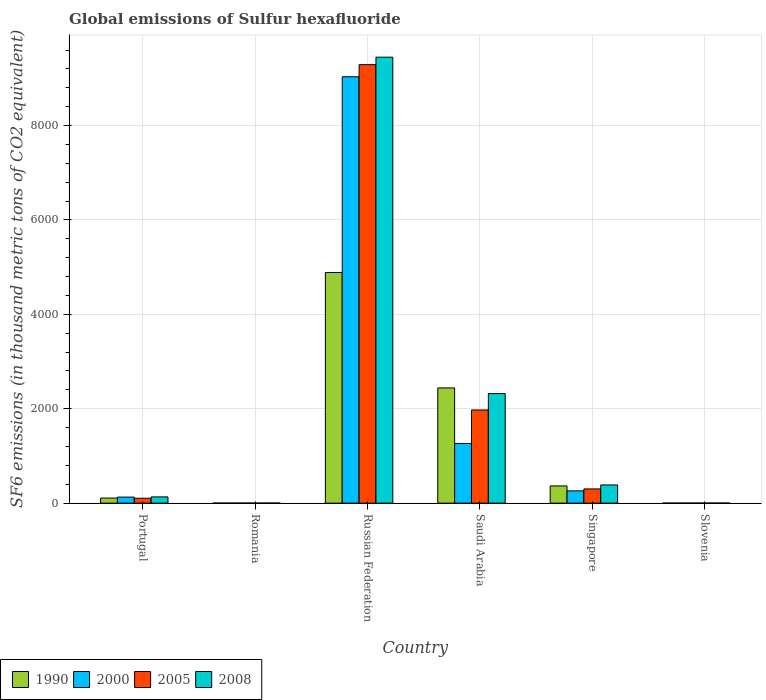How many different coloured bars are there?
Keep it short and to the point. 4. How many groups of bars are there?
Offer a terse response. 6. Are the number of bars on each tick of the X-axis equal?
Offer a very short reply. Yes. How many bars are there on the 3rd tick from the left?
Offer a terse response. 4. How many bars are there on the 6th tick from the right?
Your response must be concise. 4. What is the label of the 4th group of bars from the left?
Offer a terse response. Saudi Arabia. What is the global emissions of Sulfur hexafluoride in 2000 in Singapore?
Make the answer very short. 259.8. Across all countries, what is the maximum global emissions of Sulfur hexafluoride in 2000?
Give a very brief answer. 9033.2. In which country was the global emissions of Sulfur hexafluoride in 2000 maximum?
Your answer should be compact. Russian Federation. In which country was the global emissions of Sulfur hexafluoride in 2005 minimum?
Your answer should be compact. Romania. What is the total global emissions of Sulfur hexafluoride in 2005 in the graph?
Keep it short and to the point. 1.17e+04. What is the difference between the global emissions of Sulfur hexafluoride in 2000 in Portugal and that in Saudi Arabia?
Give a very brief answer. -1136.6. What is the difference between the global emissions of Sulfur hexafluoride in 2000 in Romania and the global emissions of Sulfur hexafluoride in 2008 in Slovenia?
Offer a terse response. -0.3. What is the average global emissions of Sulfur hexafluoride in 2005 per country?
Your answer should be very brief. 1945.52. What is the difference between the global emissions of Sulfur hexafluoride of/in 2005 and global emissions of Sulfur hexafluoride of/in 1990 in Slovenia?
Offer a terse response. 0.6. What is the ratio of the global emissions of Sulfur hexafluoride in 1990 in Portugal to that in Singapore?
Make the answer very short. 0.3. What is the difference between the highest and the second highest global emissions of Sulfur hexafluoride in 2000?
Your answer should be very brief. -7768.6. What is the difference between the highest and the lowest global emissions of Sulfur hexafluoride in 2005?
Keep it short and to the point. 9287.7. Is the sum of the global emissions of Sulfur hexafluoride in 2008 in Portugal and Romania greater than the maximum global emissions of Sulfur hexafluoride in 1990 across all countries?
Offer a very short reply. No. What does the 4th bar from the left in Romania represents?
Your answer should be compact. 2008. What does the 1st bar from the right in Portugal represents?
Offer a very short reply. 2008. What is the difference between two consecutive major ticks on the Y-axis?
Your answer should be compact. 2000. Does the graph contain grids?
Offer a very short reply. Yes. Where does the legend appear in the graph?
Your answer should be compact. Bottom left. How many legend labels are there?
Provide a succinct answer. 4. How are the legend labels stacked?
Give a very brief answer. Horizontal. What is the title of the graph?
Provide a succinct answer. Global emissions of Sulfur hexafluoride. What is the label or title of the Y-axis?
Your response must be concise. SF6 emissions (in thousand metric tons of CO2 equivalent). What is the SF6 emissions (in thousand metric tons of CO2 equivalent) of 1990 in Portugal?
Provide a succinct answer. 108. What is the SF6 emissions (in thousand metric tons of CO2 equivalent) of 2000 in Portugal?
Your answer should be compact. 128. What is the SF6 emissions (in thousand metric tons of CO2 equivalent) in 2005 in Portugal?
Offer a terse response. 103.8. What is the SF6 emissions (in thousand metric tons of CO2 equivalent) in 2008 in Portugal?
Make the answer very short. 132.4. What is the SF6 emissions (in thousand metric tons of CO2 equivalent) in 1990 in Romania?
Your answer should be very brief. 1.6. What is the SF6 emissions (in thousand metric tons of CO2 equivalent) in 2000 in Romania?
Your answer should be compact. 2. What is the SF6 emissions (in thousand metric tons of CO2 equivalent) in 2005 in Romania?
Your answer should be compact. 2.2. What is the SF6 emissions (in thousand metric tons of CO2 equivalent) of 1990 in Russian Federation?
Your answer should be very brief. 4886.8. What is the SF6 emissions (in thousand metric tons of CO2 equivalent) in 2000 in Russian Federation?
Provide a short and direct response. 9033.2. What is the SF6 emissions (in thousand metric tons of CO2 equivalent) in 2005 in Russian Federation?
Make the answer very short. 9289.9. What is the SF6 emissions (in thousand metric tons of CO2 equivalent) in 2008 in Russian Federation?
Keep it short and to the point. 9448.2. What is the SF6 emissions (in thousand metric tons of CO2 equivalent) of 1990 in Saudi Arabia?
Your answer should be compact. 2441.3. What is the SF6 emissions (in thousand metric tons of CO2 equivalent) in 2000 in Saudi Arabia?
Your answer should be compact. 1264.6. What is the SF6 emissions (in thousand metric tons of CO2 equivalent) in 2005 in Saudi Arabia?
Give a very brief answer. 1973.8. What is the SF6 emissions (in thousand metric tons of CO2 equivalent) of 2008 in Saudi Arabia?
Give a very brief answer. 2321.8. What is the SF6 emissions (in thousand metric tons of CO2 equivalent) of 1990 in Singapore?
Give a very brief answer. 364.7. What is the SF6 emissions (in thousand metric tons of CO2 equivalent) of 2000 in Singapore?
Keep it short and to the point. 259.8. What is the SF6 emissions (in thousand metric tons of CO2 equivalent) of 2005 in Singapore?
Your answer should be compact. 301.2. What is the SF6 emissions (in thousand metric tons of CO2 equivalent) in 2008 in Singapore?
Make the answer very short. 385.5. What is the SF6 emissions (in thousand metric tons of CO2 equivalent) of 2000 in Slovenia?
Keep it short and to the point. 2. What is the SF6 emissions (in thousand metric tons of CO2 equivalent) in 2008 in Slovenia?
Offer a very short reply. 2.3. Across all countries, what is the maximum SF6 emissions (in thousand metric tons of CO2 equivalent) in 1990?
Your answer should be compact. 4886.8. Across all countries, what is the maximum SF6 emissions (in thousand metric tons of CO2 equivalent) in 2000?
Offer a very short reply. 9033.2. Across all countries, what is the maximum SF6 emissions (in thousand metric tons of CO2 equivalent) of 2005?
Your response must be concise. 9289.9. Across all countries, what is the maximum SF6 emissions (in thousand metric tons of CO2 equivalent) in 2008?
Give a very brief answer. 9448.2. Across all countries, what is the minimum SF6 emissions (in thousand metric tons of CO2 equivalent) in 2000?
Provide a succinct answer. 2. Across all countries, what is the minimum SF6 emissions (in thousand metric tons of CO2 equivalent) of 2005?
Your answer should be compact. 2.2. Across all countries, what is the minimum SF6 emissions (in thousand metric tons of CO2 equivalent) in 2008?
Ensure brevity in your answer.  2.3. What is the total SF6 emissions (in thousand metric tons of CO2 equivalent) of 1990 in the graph?
Provide a succinct answer. 7804. What is the total SF6 emissions (in thousand metric tons of CO2 equivalent) in 2000 in the graph?
Provide a short and direct response. 1.07e+04. What is the total SF6 emissions (in thousand metric tons of CO2 equivalent) of 2005 in the graph?
Ensure brevity in your answer.  1.17e+04. What is the total SF6 emissions (in thousand metric tons of CO2 equivalent) in 2008 in the graph?
Ensure brevity in your answer.  1.23e+04. What is the difference between the SF6 emissions (in thousand metric tons of CO2 equivalent) in 1990 in Portugal and that in Romania?
Ensure brevity in your answer.  106.4. What is the difference between the SF6 emissions (in thousand metric tons of CO2 equivalent) of 2000 in Portugal and that in Romania?
Your response must be concise. 126. What is the difference between the SF6 emissions (in thousand metric tons of CO2 equivalent) of 2005 in Portugal and that in Romania?
Offer a terse response. 101.6. What is the difference between the SF6 emissions (in thousand metric tons of CO2 equivalent) of 2008 in Portugal and that in Romania?
Keep it short and to the point. 130.1. What is the difference between the SF6 emissions (in thousand metric tons of CO2 equivalent) in 1990 in Portugal and that in Russian Federation?
Provide a short and direct response. -4778.8. What is the difference between the SF6 emissions (in thousand metric tons of CO2 equivalent) in 2000 in Portugal and that in Russian Federation?
Your answer should be very brief. -8905.2. What is the difference between the SF6 emissions (in thousand metric tons of CO2 equivalent) of 2005 in Portugal and that in Russian Federation?
Make the answer very short. -9186.1. What is the difference between the SF6 emissions (in thousand metric tons of CO2 equivalent) of 2008 in Portugal and that in Russian Federation?
Your answer should be compact. -9315.8. What is the difference between the SF6 emissions (in thousand metric tons of CO2 equivalent) of 1990 in Portugal and that in Saudi Arabia?
Your answer should be very brief. -2333.3. What is the difference between the SF6 emissions (in thousand metric tons of CO2 equivalent) of 2000 in Portugal and that in Saudi Arabia?
Offer a terse response. -1136.6. What is the difference between the SF6 emissions (in thousand metric tons of CO2 equivalent) in 2005 in Portugal and that in Saudi Arabia?
Make the answer very short. -1870. What is the difference between the SF6 emissions (in thousand metric tons of CO2 equivalent) in 2008 in Portugal and that in Saudi Arabia?
Ensure brevity in your answer.  -2189.4. What is the difference between the SF6 emissions (in thousand metric tons of CO2 equivalent) in 1990 in Portugal and that in Singapore?
Ensure brevity in your answer.  -256.7. What is the difference between the SF6 emissions (in thousand metric tons of CO2 equivalent) in 2000 in Portugal and that in Singapore?
Provide a succinct answer. -131.8. What is the difference between the SF6 emissions (in thousand metric tons of CO2 equivalent) in 2005 in Portugal and that in Singapore?
Provide a succinct answer. -197.4. What is the difference between the SF6 emissions (in thousand metric tons of CO2 equivalent) in 2008 in Portugal and that in Singapore?
Keep it short and to the point. -253.1. What is the difference between the SF6 emissions (in thousand metric tons of CO2 equivalent) in 1990 in Portugal and that in Slovenia?
Offer a terse response. 106.4. What is the difference between the SF6 emissions (in thousand metric tons of CO2 equivalent) in 2000 in Portugal and that in Slovenia?
Ensure brevity in your answer.  126. What is the difference between the SF6 emissions (in thousand metric tons of CO2 equivalent) of 2005 in Portugal and that in Slovenia?
Your answer should be compact. 101.6. What is the difference between the SF6 emissions (in thousand metric tons of CO2 equivalent) of 2008 in Portugal and that in Slovenia?
Make the answer very short. 130.1. What is the difference between the SF6 emissions (in thousand metric tons of CO2 equivalent) in 1990 in Romania and that in Russian Federation?
Ensure brevity in your answer.  -4885.2. What is the difference between the SF6 emissions (in thousand metric tons of CO2 equivalent) in 2000 in Romania and that in Russian Federation?
Your response must be concise. -9031.2. What is the difference between the SF6 emissions (in thousand metric tons of CO2 equivalent) of 2005 in Romania and that in Russian Federation?
Your answer should be very brief. -9287.7. What is the difference between the SF6 emissions (in thousand metric tons of CO2 equivalent) in 2008 in Romania and that in Russian Federation?
Give a very brief answer. -9445.9. What is the difference between the SF6 emissions (in thousand metric tons of CO2 equivalent) of 1990 in Romania and that in Saudi Arabia?
Offer a very short reply. -2439.7. What is the difference between the SF6 emissions (in thousand metric tons of CO2 equivalent) of 2000 in Romania and that in Saudi Arabia?
Your answer should be very brief. -1262.6. What is the difference between the SF6 emissions (in thousand metric tons of CO2 equivalent) of 2005 in Romania and that in Saudi Arabia?
Give a very brief answer. -1971.6. What is the difference between the SF6 emissions (in thousand metric tons of CO2 equivalent) in 2008 in Romania and that in Saudi Arabia?
Keep it short and to the point. -2319.5. What is the difference between the SF6 emissions (in thousand metric tons of CO2 equivalent) in 1990 in Romania and that in Singapore?
Provide a succinct answer. -363.1. What is the difference between the SF6 emissions (in thousand metric tons of CO2 equivalent) of 2000 in Romania and that in Singapore?
Your answer should be compact. -257.8. What is the difference between the SF6 emissions (in thousand metric tons of CO2 equivalent) of 2005 in Romania and that in Singapore?
Offer a terse response. -299. What is the difference between the SF6 emissions (in thousand metric tons of CO2 equivalent) in 2008 in Romania and that in Singapore?
Keep it short and to the point. -383.2. What is the difference between the SF6 emissions (in thousand metric tons of CO2 equivalent) in 2000 in Romania and that in Slovenia?
Make the answer very short. 0. What is the difference between the SF6 emissions (in thousand metric tons of CO2 equivalent) in 1990 in Russian Federation and that in Saudi Arabia?
Your answer should be very brief. 2445.5. What is the difference between the SF6 emissions (in thousand metric tons of CO2 equivalent) of 2000 in Russian Federation and that in Saudi Arabia?
Ensure brevity in your answer.  7768.6. What is the difference between the SF6 emissions (in thousand metric tons of CO2 equivalent) of 2005 in Russian Federation and that in Saudi Arabia?
Provide a short and direct response. 7316.1. What is the difference between the SF6 emissions (in thousand metric tons of CO2 equivalent) in 2008 in Russian Federation and that in Saudi Arabia?
Offer a terse response. 7126.4. What is the difference between the SF6 emissions (in thousand metric tons of CO2 equivalent) of 1990 in Russian Federation and that in Singapore?
Offer a terse response. 4522.1. What is the difference between the SF6 emissions (in thousand metric tons of CO2 equivalent) in 2000 in Russian Federation and that in Singapore?
Give a very brief answer. 8773.4. What is the difference between the SF6 emissions (in thousand metric tons of CO2 equivalent) of 2005 in Russian Federation and that in Singapore?
Make the answer very short. 8988.7. What is the difference between the SF6 emissions (in thousand metric tons of CO2 equivalent) in 2008 in Russian Federation and that in Singapore?
Make the answer very short. 9062.7. What is the difference between the SF6 emissions (in thousand metric tons of CO2 equivalent) of 1990 in Russian Federation and that in Slovenia?
Offer a very short reply. 4885.2. What is the difference between the SF6 emissions (in thousand metric tons of CO2 equivalent) of 2000 in Russian Federation and that in Slovenia?
Make the answer very short. 9031.2. What is the difference between the SF6 emissions (in thousand metric tons of CO2 equivalent) of 2005 in Russian Federation and that in Slovenia?
Provide a succinct answer. 9287.7. What is the difference between the SF6 emissions (in thousand metric tons of CO2 equivalent) in 2008 in Russian Federation and that in Slovenia?
Your answer should be very brief. 9445.9. What is the difference between the SF6 emissions (in thousand metric tons of CO2 equivalent) of 1990 in Saudi Arabia and that in Singapore?
Make the answer very short. 2076.6. What is the difference between the SF6 emissions (in thousand metric tons of CO2 equivalent) in 2000 in Saudi Arabia and that in Singapore?
Give a very brief answer. 1004.8. What is the difference between the SF6 emissions (in thousand metric tons of CO2 equivalent) in 2005 in Saudi Arabia and that in Singapore?
Your response must be concise. 1672.6. What is the difference between the SF6 emissions (in thousand metric tons of CO2 equivalent) of 2008 in Saudi Arabia and that in Singapore?
Keep it short and to the point. 1936.3. What is the difference between the SF6 emissions (in thousand metric tons of CO2 equivalent) in 1990 in Saudi Arabia and that in Slovenia?
Your response must be concise. 2439.7. What is the difference between the SF6 emissions (in thousand metric tons of CO2 equivalent) of 2000 in Saudi Arabia and that in Slovenia?
Keep it short and to the point. 1262.6. What is the difference between the SF6 emissions (in thousand metric tons of CO2 equivalent) of 2005 in Saudi Arabia and that in Slovenia?
Offer a terse response. 1971.6. What is the difference between the SF6 emissions (in thousand metric tons of CO2 equivalent) of 2008 in Saudi Arabia and that in Slovenia?
Provide a short and direct response. 2319.5. What is the difference between the SF6 emissions (in thousand metric tons of CO2 equivalent) of 1990 in Singapore and that in Slovenia?
Ensure brevity in your answer.  363.1. What is the difference between the SF6 emissions (in thousand metric tons of CO2 equivalent) of 2000 in Singapore and that in Slovenia?
Your answer should be compact. 257.8. What is the difference between the SF6 emissions (in thousand metric tons of CO2 equivalent) in 2005 in Singapore and that in Slovenia?
Ensure brevity in your answer.  299. What is the difference between the SF6 emissions (in thousand metric tons of CO2 equivalent) of 2008 in Singapore and that in Slovenia?
Your answer should be compact. 383.2. What is the difference between the SF6 emissions (in thousand metric tons of CO2 equivalent) of 1990 in Portugal and the SF6 emissions (in thousand metric tons of CO2 equivalent) of 2000 in Romania?
Offer a very short reply. 106. What is the difference between the SF6 emissions (in thousand metric tons of CO2 equivalent) of 1990 in Portugal and the SF6 emissions (in thousand metric tons of CO2 equivalent) of 2005 in Romania?
Your answer should be compact. 105.8. What is the difference between the SF6 emissions (in thousand metric tons of CO2 equivalent) of 1990 in Portugal and the SF6 emissions (in thousand metric tons of CO2 equivalent) of 2008 in Romania?
Provide a short and direct response. 105.7. What is the difference between the SF6 emissions (in thousand metric tons of CO2 equivalent) in 2000 in Portugal and the SF6 emissions (in thousand metric tons of CO2 equivalent) in 2005 in Romania?
Your answer should be compact. 125.8. What is the difference between the SF6 emissions (in thousand metric tons of CO2 equivalent) of 2000 in Portugal and the SF6 emissions (in thousand metric tons of CO2 equivalent) of 2008 in Romania?
Your answer should be compact. 125.7. What is the difference between the SF6 emissions (in thousand metric tons of CO2 equivalent) of 2005 in Portugal and the SF6 emissions (in thousand metric tons of CO2 equivalent) of 2008 in Romania?
Give a very brief answer. 101.5. What is the difference between the SF6 emissions (in thousand metric tons of CO2 equivalent) in 1990 in Portugal and the SF6 emissions (in thousand metric tons of CO2 equivalent) in 2000 in Russian Federation?
Give a very brief answer. -8925.2. What is the difference between the SF6 emissions (in thousand metric tons of CO2 equivalent) in 1990 in Portugal and the SF6 emissions (in thousand metric tons of CO2 equivalent) in 2005 in Russian Federation?
Provide a succinct answer. -9181.9. What is the difference between the SF6 emissions (in thousand metric tons of CO2 equivalent) in 1990 in Portugal and the SF6 emissions (in thousand metric tons of CO2 equivalent) in 2008 in Russian Federation?
Provide a short and direct response. -9340.2. What is the difference between the SF6 emissions (in thousand metric tons of CO2 equivalent) in 2000 in Portugal and the SF6 emissions (in thousand metric tons of CO2 equivalent) in 2005 in Russian Federation?
Your response must be concise. -9161.9. What is the difference between the SF6 emissions (in thousand metric tons of CO2 equivalent) of 2000 in Portugal and the SF6 emissions (in thousand metric tons of CO2 equivalent) of 2008 in Russian Federation?
Give a very brief answer. -9320.2. What is the difference between the SF6 emissions (in thousand metric tons of CO2 equivalent) in 2005 in Portugal and the SF6 emissions (in thousand metric tons of CO2 equivalent) in 2008 in Russian Federation?
Make the answer very short. -9344.4. What is the difference between the SF6 emissions (in thousand metric tons of CO2 equivalent) in 1990 in Portugal and the SF6 emissions (in thousand metric tons of CO2 equivalent) in 2000 in Saudi Arabia?
Your answer should be very brief. -1156.6. What is the difference between the SF6 emissions (in thousand metric tons of CO2 equivalent) of 1990 in Portugal and the SF6 emissions (in thousand metric tons of CO2 equivalent) of 2005 in Saudi Arabia?
Provide a short and direct response. -1865.8. What is the difference between the SF6 emissions (in thousand metric tons of CO2 equivalent) in 1990 in Portugal and the SF6 emissions (in thousand metric tons of CO2 equivalent) in 2008 in Saudi Arabia?
Give a very brief answer. -2213.8. What is the difference between the SF6 emissions (in thousand metric tons of CO2 equivalent) in 2000 in Portugal and the SF6 emissions (in thousand metric tons of CO2 equivalent) in 2005 in Saudi Arabia?
Offer a very short reply. -1845.8. What is the difference between the SF6 emissions (in thousand metric tons of CO2 equivalent) of 2000 in Portugal and the SF6 emissions (in thousand metric tons of CO2 equivalent) of 2008 in Saudi Arabia?
Your answer should be very brief. -2193.8. What is the difference between the SF6 emissions (in thousand metric tons of CO2 equivalent) of 2005 in Portugal and the SF6 emissions (in thousand metric tons of CO2 equivalent) of 2008 in Saudi Arabia?
Ensure brevity in your answer.  -2218. What is the difference between the SF6 emissions (in thousand metric tons of CO2 equivalent) of 1990 in Portugal and the SF6 emissions (in thousand metric tons of CO2 equivalent) of 2000 in Singapore?
Provide a succinct answer. -151.8. What is the difference between the SF6 emissions (in thousand metric tons of CO2 equivalent) of 1990 in Portugal and the SF6 emissions (in thousand metric tons of CO2 equivalent) of 2005 in Singapore?
Ensure brevity in your answer.  -193.2. What is the difference between the SF6 emissions (in thousand metric tons of CO2 equivalent) of 1990 in Portugal and the SF6 emissions (in thousand metric tons of CO2 equivalent) of 2008 in Singapore?
Provide a short and direct response. -277.5. What is the difference between the SF6 emissions (in thousand metric tons of CO2 equivalent) of 2000 in Portugal and the SF6 emissions (in thousand metric tons of CO2 equivalent) of 2005 in Singapore?
Keep it short and to the point. -173.2. What is the difference between the SF6 emissions (in thousand metric tons of CO2 equivalent) in 2000 in Portugal and the SF6 emissions (in thousand metric tons of CO2 equivalent) in 2008 in Singapore?
Make the answer very short. -257.5. What is the difference between the SF6 emissions (in thousand metric tons of CO2 equivalent) in 2005 in Portugal and the SF6 emissions (in thousand metric tons of CO2 equivalent) in 2008 in Singapore?
Offer a terse response. -281.7. What is the difference between the SF6 emissions (in thousand metric tons of CO2 equivalent) in 1990 in Portugal and the SF6 emissions (in thousand metric tons of CO2 equivalent) in 2000 in Slovenia?
Offer a terse response. 106. What is the difference between the SF6 emissions (in thousand metric tons of CO2 equivalent) of 1990 in Portugal and the SF6 emissions (in thousand metric tons of CO2 equivalent) of 2005 in Slovenia?
Keep it short and to the point. 105.8. What is the difference between the SF6 emissions (in thousand metric tons of CO2 equivalent) in 1990 in Portugal and the SF6 emissions (in thousand metric tons of CO2 equivalent) in 2008 in Slovenia?
Your answer should be very brief. 105.7. What is the difference between the SF6 emissions (in thousand metric tons of CO2 equivalent) in 2000 in Portugal and the SF6 emissions (in thousand metric tons of CO2 equivalent) in 2005 in Slovenia?
Offer a very short reply. 125.8. What is the difference between the SF6 emissions (in thousand metric tons of CO2 equivalent) of 2000 in Portugal and the SF6 emissions (in thousand metric tons of CO2 equivalent) of 2008 in Slovenia?
Provide a succinct answer. 125.7. What is the difference between the SF6 emissions (in thousand metric tons of CO2 equivalent) of 2005 in Portugal and the SF6 emissions (in thousand metric tons of CO2 equivalent) of 2008 in Slovenia?
Give a very brief answer. 101.5. What is the difference between the SF6 emissions (in thousand metric tons of CO2 equivalent) in 1990 in Romania and the SF6 emissions (in thousand metric tons of CO2 equivalent) in 2000 in Russian Federation?
Your answer should be compact. -9031.6. What is the difference between the SF6 emissions (in thousand metric tons of CO2 equivalent) in 1990 in Romania and the SF6 emissions (in thousand metric tons of CO2 equivalent) in 2005 in Russian Federation?
Give a very brief answer. -9288.3. What is the difference between the SF6 emissions (in thousand metric tons of CO2 equivalent) in 1990 in Romania and the SF6 emissions (in thousand metric tons of CO2 equivalent) in 2008 in Russian Federation?
Offer a terse response. -9446.6. What is the difference between the SF6 emissions (in thousand metric tons of CO2 equivalent) in 2000 in Romania and the SF6 emissions (in thousand metric tons of CO2 equivalent) in 2005 in Russian Federation?
Your answer should be compact. -9287.9. What is the difference between the SF6 emissions (in thousand metric tons of CO2 equivalent) in 2000 in Romania and the SF6 emissions (in thousand metric tons of CO2 equivalent) in 2008 in Russian Federation?
Ensure brevity in your answer.  -9446.2. What is the difference between the SF6 emissions (in thousand metric tons of CO2 equivalent) in 2005 in Romania and the SF6 emissions (in thousand metric tons of CO2 equivalent) in 2008 in Russian Federation?
Your answer should be compact. -9446. What is the difference between the SF6 emissions (in thousand metric tons of CO2 equivalent) of 1990 in Romania and the SF6 emissions (in thousand metric tons of CO2 equivalent) of 2000 in Saudi Arabia?
Offer a terse response. -1263. What is the difference between the SF6 emissions (in thousand metric tons of CO2 equivalent) of 1990 in Romania and the SF6 emissions (in thousand metric tons of CO2 equivalent) of 2005 in Saudi Arabia?
Offer a terse response. -1972.2. What is the difference between the SF6 emissions (in thousand metric tons of CO2 equivalent) in 1990 in Romania and the SF6 emissions (in thousand metric tons of CO2 equivalent) in 2008 in Saudi Arabia?
Give a very brief answer. -2320.2. What is the difference between the SF6 emissions (in thousand metric tons of CO2 equivalent) of 2000 in Romania and the SF6 emissions (in thousand metric tons of CO2 equivalent) of 2005 in Saudi Arabia?
Your response must be concise. -1971.8. What is the difference between the SF6 emissions (in thousand metric tons of CO2 equivalent) in 2000 in Romania and the SF6 emissions (in thousand metric tons of CO2 equivalent) in 2008 in Saudi Arabia?
Provide a succinct answer. -2319.8. What is the difference between the SF6 emissions (in thousand metric tons of CO2 equivalent) of 2005 in Romania and the SF6 emissions (in thousand metric tons of CO2 equivalent) of 2008 in Saudi Arabia?
Offer a very short reply. -2319.6. What is the difference between the SF6 emissions (in thousand metric tons of CO2 equivalent) in 1990 in Romania and the SF6 emissions (in thousand metric tons of CO2 equivalent) in 2000 in Singapore?
Provide a succinct answer. -258.2. What is the difference between the SF6 emissions (in thousand metric tons of CO2 equivalent) in 1990 in Romania and the SF6 emissions (in thousand metric tons of CO2 equivalent) in 2005 in Singapore?
Give a very brief answer. -299.6. What is the difference between the SF6 emissions (in thousand metric tons of CO2 equivalent) in 1990 in Romania and the SF6 emissions (in thousand metric tons of CO2 equivalent) in 2008 in Singapore?
Your answer should be compact. -383.9. What is the difference between the SF6 emissions (in thousand metric tons of CO2 equivalent) in 2000 in Romania and the SF6 emissions (in thousand metric tons of CO2 equivalent) in 2005 in Singapore?
Offer a terse response. -299.2. What is the difference between the SF6 emissions (in thousand metric tons of CO2 equivalent) in 2000 in Romania and the SF6 emissions (in thousand metric tons of CO2 equivalent) in 2008 in Singapore?
Your answer should be compact. -383.5. What is the difference between the SF6 emissions (in thousand metric tons of CO2 equivalent) in 2005 in Romania and the SF6 emissions (in thousand metric tons of CO2 equivalent) in 2008 in Singapore?
Offer a very short reply. -383.3. What is the difference between the SF6 emissions (in thousand metric tons of CO2 equivalent) of 1990 in Romania and the SF6 emissions (in thousand metric tons of CO2 equivalent) of 2000 in Slovenia?
Keep it short and to the point. -0.4. What is the difference between the SF6 emissions (in thousand metric tons of CO2 equivalent) of 1990 in Romania and the SF6 emissions (in thousand metric tons of CO2 equivalent) of 2005 in Slovenia?
Provide a succinct answer. -0.6. What is the difference between the SF6 emissions (in thousand metric tons of CO2 equivalent) in 2000 in Romania and the SF6 emissions (in thousand metric tons of CO2 equivalent) in 2005 in Slovenia?
Provide a short and direct response. -0.2. What is the difference between the SF6 emissions (in thousand metric tons of CO2 equivalent) of 2005 in Romania and the SF6 emissions (in thousand metric tons of CO2 equivalent) of 2008 in Slovenia?
Keep it short and to the point. -0.1. What is the difference between the SF6 emissions (in thousand metric tons of CO2 equivalent) in 1990 in Russian Federation and the SF6 emissions (in thousand metric tons of CO2 equivalent) in 2000 in Saudi Arabia?
Keep it short and to the point. 3622.2. What is the difference between the SF6 emissions (in thousand metric tons of CO2 equivalent) of 1990 in Russian Federation and the SF6 emissions (in thousand metric tons of CO2 equivalent) of 2005 in Saudi Arabia?
Provide a succinct answer. 2913. What is the difference between the SF6 emissions (in thousand metric tons of CO2 equivalent) in 1990 in Russian Federation and the SF6 emissions (in thousand metric tons of CO2 equivalent) in 2008 in Saudi Arabia?
Offer a very short reply. 2565. What is the difference between the SF6 emissions (in thousand metric tons of CO2 equivalent) in 2000 in Russian Federation and the SF6 emissions (in thousand metric tons of CO2 equivalent) in 2005 in Saudi Arabia?
Provide a short and direct response. 7059.4. What is the difference between the SF6 emissions (in thousand metric tons of CO2 equivalent) in 2000 in Russian Federation and the SF6 emissions (in thousand metric tons of CO2 equivalent) in 2008 in Saudi Arabia?
Give a very brief answer. 6711.4. What is the difference between the SF6 emissions (in thousand metric tons of CO2 equivalent) of 2005 in Russian Federation and the SF6 emissions (in thousand metric tons of CO2 equivalent) of 2008 in Saudi Arabia?
Your answer should be very brief. 6968.1. What is the difference between the SF6 emissions (in thousand metric tons of CO2 equivalent) in 1990 in Russian Federation and the SF6 emissions (in thousand metric tons of CO2 equivalent) in 2000 in Singapore?
Your answer should be very brief. 4627. What is the difference between the SF6 emissions (in thousand metric tons of CO2 equivalent) of 1990 in Russian Federation and the SF6 emissions (in thousand metric tons of CO2 equivalent) of 2005 in Singapore?
Your answer should be compact. 4585.6. What is the difference between the SF6 emissions (in thousand metric tons of CO2 equivalent) of 1990 in Russian Federation and the SF6 emissions (in thousand metric tons of CO2 equivalent) of 2008 in Singapore?
Make the answer very short. 4501.3. What is the difference between the SF6 emissions (in thousand metric tons of CO2 equivalent) of 2000 in Russian Federation and the SF6 emissions (in thousand metric tons of CO2 equivalent) of 2005 in Singapore?
Give a very brief answer. 8732. What is the difference between the SF6 emissions (in thousand metric tons of CO2 equivalent) in 2000 in Russian Federation and the SF6 emissions (in thousand metric tons of CO2 equivalent) in 2008 in Singapore?
Provide a short and direct response. 8647.7. What is the difference between the SF6 emissions (in thousand metric tons of CO2 equivalent) of 2005 in Russian Federation and the SF6 emissions (in thousand metric tons of CO2 equivalent) of 2008 in Singapore?
Keep it short and to the point. 8904.4. What is the difference between the SF6 emissions (in thousand metric tons of CO2 equivalent) of 1990 in Russian Federation and the SF6 emissions (in thousand metric tons of CO2 equivalent) of 2000 in Slovenia?
Ensure brevity in your answer.  4884.8. What is the difference between the SF6 emissions (in thousand metric tons of CO2 equivalent) of 1990 in Russian Federation and the SF6 emissions (in thousand metric tons of CO2 equivalent) of 2005 in Slovenia?
Provide a succinct answer. 4884.6. What is the difference between the SF6 emissions (in thousand metric tons of CO2 equivalent) of 1990 in Russian Federation and the SF6 emissions (in thousand metric tons of CO2 equivalent) of 2008 in Slovenia?
Your response must be concise. 4884.5. What is the difference between the SF6 emissions (in thousand metric tons of CO2 equivalent) of 2000 in Russian Federation and the SF6 emissions (in thousand metric tons of CO2 equivalent) of 2005 in Slovenia?
Provide a short and direct response. 9031. What is the difference between the SF6 emissions (in thousand metric tons of CO2 equivalent) of 2000 in Russian Federation and the SF6 emissions (in thousand metric tons of CO2 equivalent) of 2008 in Slovenia?
Your answer should be compact. 9030.9. What is the difference between the SF6 emissions (in thousand metric tons of CO2 equivalent) of 2005 in Russian Federation and the SF6 emissions (in thousand metric tons of CO2 equivalent) of 2008 in Slovenia?
Your response must be concise. 9287.6. What is the difference between the SF6 emissions (in thousand metric tons of CO2 equivalent) in 1990 in Saudi Arabia and the SF6 emissions (in thousand metric tons of CO2 equivalent) in 2000 in Singapore?
Give a very brief answer. 2181.5. What is the difference between the SF6 emissions (in thousand metric tons of CO2 equivalent) of 1990 in Saudi Arabia and the SF6 emissions (in thousand metric tons of CO2 equivalent) of 2005 in Singapore?
Provide a short and direct response. 2140.1. What is the difference between the SF6 emissions (in thousand metric tons of CO2 equivalent) in 1990 in Saudi Arabia and the SF6 emissions (in thousand metric tons of CO2 equivalent) in 2008 in Singapore?
Offer a very short reply. 2055.8. What is the difference between the SF6 emissions (in thousand metric tons of CO2 equivalent) of 2000 in Saudi Arabia and the SF6 emissions (in thousand metric tons of CO2 equivalent) of 2005 in Singapore?
Your answer should be compact. 963.4. What is the difference between the SF6 emissions (in thousand metric tons of CO2 equivalent) of 2000 in Saudi Arabia and the SF6 emissions (in thousand metric tons of CO2 equivalent) of 2008 in Singapore?
Your answer should be very brief. 879.1. What is the difference between the SF6 emissions (in thousand metric tons of CO2 equivalent) in 2005 in Saudi Arabia and the SF6 emissions (in thousand metric tons of CO2 equivalent) in 2008 in Singapore?
Offer a terse response. 1588.3. What is the difference between the SF6 emissions (in thousand metric tons of CO2 equivalent) of 1990 in Saudi Arabia and the SF6 emissions (in thousand metric tons of CO2 equivalent) of 2000 in Slovenia?
Your answer should be compact. 2439.3. What is the difference between the SF6 emissions (in thousand metric tons of CO2 equivalent) in 1990 in Saudi Arabia and the SF6 emissions (in thousand metric tons of CO2 equivalent) in 2005 in Slovenia?
Offer a very short reply. 2439.1. What is the difference between the SF6 emissions (in thousand metric tons of CO2 equivalent) of 1990 in Saudi Arabia and the SF6 emissions (in thousand metric tons of CO2 equivalent) of 2008 in Slovenia?
Give a very brief answer. 2439. What is the difference between the SF6 emissions (in thousand metric tons of CO2 equivalent) in 2000 in Saudi Arabia and the SF6 emissions (in thousand metric tons of CO2 equivalent) in 2005 in Slovenia?
Provide a short and direct response. 1262.4. What is the difference between the SF6 emissions (in thousand metric tons of CO2 equivalent) of 2000 in Saudi Arabia and the SF6 emissions (in thousand metric tons of CO2 equivalent) of 2008 in Slovenia?
Offer a terse response. 1262.3. What is the difference between the SF6 emissions (in thousand metric tons of CO2 equivalent) in 2005 in Saudi Arabia and the SF6 emissions (in thousand metric tons of CO2 equivalent) in 2008 in Slovenia?
Offer a terse response. 1971.5. What is the difference between the SF6 emissions (in thousand metric tons of CO2 equivalent) of 1990 in Singapore and the SF6 emissions (in thousand metric tons of CO2 equivalent) of 2000 in Slovenia?
Your response must be concise. 362.7. What is the difference between the SF6 emissions (in thousand metric tons of CO2 equivalent) in 1990 in Singapore and the SF6 emissions (in thousand metric tons of CO2 equivalent) in 2005 in Slovenia?
Your answer should be compact. 362.5. What is the difference between the SF6 emissions (in thousand metric tons of CO2 equivalent) in 1990 in Singapore and the SF6 emissions (in thousand metric tons of CO2 equivalent) in 2008 in Slovenia?
Ensure brevity in your answer.  362.4. What is the difference between the SF6 emissions (in thousand metric tons of CO2 equivalent) in 2000 in Singapore and the SF6 emissions (in thousand metric tons of CO2 equivalent) in 2005 in Slovenia?
Provide a short and direct response. 257.6. What is the difference between the SF6 emissions (in thousand metric tons of CO2 equivalent) in 2000 in Singapore and the SF6 emissions (in thousand metric tons of CO2 equivalent) in 2008 in Slovenia?
Your response must be concise. 257.5. What is the difference between the SF6 emissions (in thousand metric tons of CO2 equivalent) of 2005 in Singapore and the SF6 emissions (in thousand metric tons of CO2 equivalent) of 2008 in Slovenia?
Keep it short and to the point. 298.9. What is the average SF6 emissions (in thousand metric tons of CO2 equivalent) in 1990 per country?
Keep it short and to the point. 1300.67. What is the average SF6 emissions (in thousand metric tons of CO2 equivalent) in 2000 per country?
Give a very brief answer. 1781.6. What is the average SF6 emissions (in thousand metric tons of CO2 equivalent) of 2005 per country?
Ensure brevity in your answer.  1945.52. What is the average SF6 emissions (in thousand metric tons of CO2 equivalent) of 2008 per country?
Offer a very short reply. 2048.75. What is the difference between the SF6 emissions (in thousand metric tons of CO2 equivalent) of 1990 and SF6 emissions (in thousand metric tons of CO2 equivalent) of 2008 in Portugal?
Offer a terse response. -24.4. What is the difference between the SF6 emissions (in thousand metric tons of CO2 equivalent) in 2000 and SF6 emissions (in thousand metric tons of CO2 equivalent) in 2005 in Portugal?
Your answer should be compact. 24.2. What is the difference between the SF6 emissions (in thousand metric tons of CO2 equivalent) of 2005 and SF6 emissions (in thousand metric tons of CO2 equivalent) of 2008 in Portugal?
Keep it short and to the point. -28.6. What is the difference between the SF6 emissions (in thousand metric tons of CO2 equivalent) in 2000 and SF6 emissions (in thousand metric tons of CO2 equivalent) in 2005 in Romania?
Your answer should be compact. -0.2. What is the difference between the SF6 emissions (in thousand metric tons of CO2 equivalent) of 1990 and SF6 emissions (in thousand metric tons of CO2 equivalent) of 2000 in Russian Federation?
Your response must be concise. -4146.4. What is the difference between the SF6 emissions (in thousand metric tons of CO2 equivalent) of 1990 and SF6 emissions (in thousand metric tons of CO2 equivalent) of 2005 in Russian Federation?
Make the answer very short. -4403.1. What is the difference between the SF6 emissions (in thousand metric tons of CO2 equivalent) in 1990 and SF6 emissions (in thousand metric tons of CO2 equivalent) in 2008 in Russian Federation?
Make the answer very short. -4561.4. What is the difference between the SF6 emissions (in thousand metric tons of CO2 equivalent) of 2000 and SF6 emissions (in thousand metric tons of CO2 equivalent) of 2005 in Russian Federation?
Your answer should be compact. -256.7. What is the difference between the SF6 emissions (in thousand metric tons of CO2 equivalent) of 2000 and SF6 emissions (in thousand metric tons of CO2 equivalent) of 2008 in Russian Federation?
Provide a short and direct response. -415. What is the difference between the SF6 emissions (in thousand metric tons of CO2 equivalent) in 2005 and SF6 emissions (in thousand metric tons of CO2 equivalent) in 2008 in Russian Federation?
Your response must be concise. -158.3. What is the difference between the SF6 emissions (in thousand metric tons of CO2 equivalent) in 1990 and SF6 emissions (in thousand metric tons of CO2 equivalent) in 2000 in Saudi Arabia?
Ensure brevity in your answer.  1176.7. What is the difference between the SF6 emissions (in thousand metric tons of CO2 equivalent) of 1990 and SF6 emissions (in thousand metric tons of CO2 equivalent) of 2005 in Saudi Arabia?
Give a very brief answer. 467.5. What is the difference between the SF6 emissions (in thousand metric tons of CO2 equivalent) of 1990 and SF6 emissions (in thousand metric tons of CO2 equivalent) of 2008 in Saudi Arabia?
Provide a succinct answer. 119.5. What is the difference between the SF6 emissions (in thousand metric tons of CO2 equivalent) in 2000 and SF6 emissions (in thousand metric tons of CO2 equivalent) in 2005 in Saudi Arabia?
Your response must be concise. -709.2. What is the difference between the SF6 emissions (in thousand metric tons of CO2 equivalent) of 2000 and SF6 emissions (in thousand metric tons of CO2 equivalent) of 2008 in Saudi Arabia?
Offer a very short reply. -1057.2. What is the difference between the SF6 emissions (in thousand metric tons of CO2 equivalent) of 2005 and SF6 emissions (in thousand metric tons of CO2 equivalent) of 2008 in Saudi Arabia?
Offer a very short reply. -348. What is the difference between the SF6 emissions (in thousand metric tons of CO2 equivalent) in 1990 and SF6 emissions (in thousand metric tons of CO2 equivalent) in 2000 in Singapore?
Keep it short and to the point. 104.9. What is the difference between the SF6 emissions (in thousand metric tons of CO2 equivalent) of 1990 and SF6 emissions (in thousand metric tons of CO2 equivalent) of 2005 in Singapore?
Ensure brevity in your answer.  63.5. What is the difference between the SF6 emissions (in thousand metric tons of CO2 equivalent) of 1990 and SF6 emissions (in thousand metric tons of CO2 equivalent) of 2008 in Singapore?
Keep it short and to the point. -20.8. What is the difference between the SF6 emissions (in thousand metric tons of CO2 equivalent) of 2000 and SF6 emissions (in thousand metric tons of CO2 equivalent) of 2005 in Singapore?
Your answer should be compact. -41.4. What is the difference between the SF6 emissions (in thousand metric tons of CO2 equivalent) in 2000 and SF6 emissions (in thousand metric tons of CO2 equivalent) in 2008 in Singapore?
Offer a terse response. -125.7. What is the difference between the SF6 emissions (in thousand metric tons of CO2 equivalent) in 2005 and SF6 emissions (in thousand metric tons of CO2 equivalent) in 2008 in Singapore?
Ensure brevity in your answer.  -84.3. What is the difference between the SF6 emissions (in thousand metric tons of CO2 equivalent) of 1990 and SF6 emissions (in thousand metric tons of CO2 equivalent) of 2000 in Slovenia?
Offer a terse response. -0.4. What is the difference between the SF6 emissions (in thousand metric tons of CO2 equivalent) in 1990 and SF6 emissions (in thousand metric tons of CO2 equivalent) in 2005 in Slovenia?
Your answer should be compact. -0.6. What is the difference between the SF6 emissions (in thousand metric tons of CO2 equivalent) in 1990 and SF6 emissions (in thousand metric tons of CO2 equivalent) in 2008 in Slovenia?
Offer a very short reply. -0.7. What is the difference between the SF6 emissions (in thousand metric tons of CO2 equivalent) of 2005 and SF6 emissions (in thousand metric tons of CO2 equivalent) of 2008 in Slovenia?
Make the answer very short. -0.1. What is the ratio of the SF6 emissions (in thousand metric tons of CO2 equivalent) of 1990 in Portugal to that in Romania?
Provide a succinct answer. 67.5. What is the ratio of the SF6 emissions (in thousand metric tons of CO2 equivalent) in 2005 in Portugal to that in Romania?
Your response must be concise. 47.18. What is the ratio of the SF6 emissions (in thousand metric tons of CO2 equivalent) in 2008 in Portugal to that in Romania?
Keep it short and to the point. 57.57. What is the ratio of the SF6 emissions (in thousand metric tons of CO2 equivalent) in 1990 in Portugal to that in Russian Federation?
Your response must be concise. 0.02. What is the ratio of the SF6 emissions (in thousand metric tons of CO2 equivalent) in 2000 in Portugal to that in Russian Federation?
Make the answer very short. 0.01. What is the ratio of the SF6 emissions (in thousand metric tons of CO2 equivalent) of 2005 in Portugal to that in Russian Federation?
Offer a terse response. 0.01. What is the ratio of the SF6 emissions (in thousand metric tons of CO2 equivalent) in 2008 in Portugal to that in Russian Federation?
Your response must be concise. 0.01. What is the ratio of the SF6 emissions (in thousand metric tons of CO2 equivalent) of 1990 in Portugal to that in Saudi Arabia?
Provide a short and direct response. 0.04. What is the ratio of the SF6 emissions (in thousand metric tons of CO2 equivalent) in 2000 in Portugal to that in Saudi Arabia?
Your answer should be compact. 0.1. What is the ratio of the SF6 emissions (in thousand metric tons of CO2 equivalent) in 2005 in Portugal to that in Saudi Arabia?
Your response must be concise. 0.05. What is the ratio of the SF6 emissions (in thousand metric tons of CO2 equivalent) in 2008 in Portugal to that in Saudi Arabia?
Provide a succinct answer. 0.06. What is the ratio of the SF6 emissions (in thousand metric tons of CO2 equivalent) of 1990 in Portugal to that in Singapore?
Make the answer very short. 0.3. What is the ratio of the SF6 emissions (in thousand metric tons of CO2 equivalent) of 2000 in Portugal to that in Singapore?
Your answer should be very brief. 0.49. What is the ratio of the SF6 emissions (in thousand metric tons of CO2 equivalent) in 2005 in Portugal to that in Singapore?
Offer a terse response. 0.34. What is the ratio of the SF6 emissions (in thousand metric tons of CO2 equivalent) of 2008 in Portugal to that in Singapore?
Offer a very short reply. 0.34. What is the ratio of the SF6 emissions (in thousand metric tons of CO2 equivalent) of 1990 in Portugal to that in Slovenia?
Your answer should be very brief. 67.5. What is the ratio of the SF6 emissions (in thousand metric tons of CO2 equivalent) of 2005 in Portugal to that in Slovenia?
Your response must be concise. 47.18. What is the ratio of the SF6 emissions (in thousand metric tons of CO2 equivalent) of 2008 in Portugal to that in Slovenia?
Keep it short and to the point. 57.57. What is the ratio of the SF6 emissions (in thousand metric tons of CO2 equivalent) of 2000 in Romania to that in Russian Federation?
Your answer should be very brief. 0. What is the ratio of the SF6 emissions (in thousand metric tons of CO2 equivalent) in 1990 in Romania to that in Saudi Arabia?
Your answer should be very brief. 0. What is the ratio of the SF6 emissions (in thousand metric tons of CO2 equivalent) in 2000 in Romania to that in Saudi Arabia?
Keep it short and to the point. 0. What is the ratio of the SF6 emissions (in thousand metric tons of CO2 equivalent) in 2005 in Romania to that in Saudi Arabia?
Provide a succinct answer. 0. What is the ratio of the SF6 emissions (in thousand metric tons of CO2 equivalent) in 2008 in Romania to that in Saudi Arabia?
Your response must be concise. 0. What is the ratio of the SF6 emissions (in thousand metric tons of CO2 equivalent) in 1990 in Romania to that in Singapore?
Ensure brevity in your answer.  0. What is the ratio of the SF6 emissions (in thousand metric tons of CO2 equivalent) of 2000 in Romania to that in Singapore?
Keep it short and to the point. 0.01. What is the ratio of the SF6 emissions (in thousand metric tons of CO2 equivalent) of 2005 in Romania to that in Singapore?
Your answer should be very brief. 0.01. What is the ratio of the SF6 emissions (in thousand metric tons of CO2 equivalent) in 2008 in Romania to that in Singapore?
Offer a terse response. 0.01. What is the ratio of the SF6 emissions (in thousand metric tons of CO2 equivalent) in 1990 in Romania to that in Slovenia?
Give a very brief answer. 1. What is the ratio of the SF6 emissions (in thousand metric tons of CO2 equivalent) of 2005 in Romania to that in Slovenia?
Give a very brief answer. 1. What is the ratio of the SF6 emissions (in thousand metric tons of CO2 equivalent) of 1990 in Russian Federation to that in Saudi Arabia?
Offer a very short reply. 2. What is the ratio of the SF6 emissions (in thousand metric tons of CO2 equivalent) in 2000 in Russian Federation to that in Saudi Arabia?
Your answer should be compact. 7.14. What is the ratio of the SF6 emissions (in thousand metric tons of CO2 equivalent) of 2005 in Russian Federation to that in Saudi Arabia?
Provide a succinct answer. 4.71. What is the ratio of the SF6 emissions (in thousand metric tons of CO2 equivalent) in 2008 in Russian Federation to that in Saudi Arabia?
Offer a very short reply. 4.07. What is the ratio of the SF6 emissions (in thousand metric tons of CO2 equivalent) of 1990 in Russian Federation to that in Singapore?
Give a very brief answer. 13.4. What is the ratio of the SF6 emissions (in thousand metric tons of CO2 equivalent) in 2000 in Russian Federation to that in Singapore?
Ensure brevity in your answer.  34.77. What is the ratio of the SF6 emissions (in thousand metric tons of CO2 equivalent) in 2005 in Russian Federation to that in Singapore?
Your response must be concise. 30.84. What is the ratio of the SF6 emissions (in thousand metric tons of CO2 equivalent) in 2008 in Russian Federation to that in Singapore?
Provide a short and direct response. 24.51. What is the ratio of the SF6 emissions (in thousand metric tons of CO2 equivalent) of 1990 in Russian Federation to that in Slovenia?
Ensure brevity in your answer.  3054.25. What is the ratio of the SF6 emissions (in thousand metric tons of CO2 equivalent) in 2000 in Russian Federation to that in Slovenia?
Your answer should be very brief. 4516.6. What is the ratio of the SF6 emissions (in thousand metric tons of CO2 equivalent) of 2005 in Russian Federation to that in Slovenia?
Provide a succinct answer. 4222.68. What is the ratio of the SF6 emissions (in thousand metric tons of CO2 equivalent) of 2008 in Russian Federation to that in Slovenia?
Provide a short and direct response. 4107.91. What is the ratio of the SF6 emissions (in thousand metric tons of CO2 equivalent) of 1990 in Saudi Arabia to that in Singapore?
Keep it short and to the point. 6.69. What is the ratio of the SF6 emissions (in thousand metric tons of CO2 equivalent) of 2000 in Saudi Arabia to that in Singapore?
Offer a very short reply. 4.87. What is the ratio of the SF6 emissions (in thousand metric tons of CO2 equivalent) in 2005 in Saudi Arabia to that in Singapore?
Offer a very short reply. 6.55. What is the ratio of the SF6 emissions (in thousand metric tons of CO2 equivalent) in 2008 in Saudi Arabia to that in Singapore?
Provide a succinct answer. 6.02. What is the ratio of the SF6 emissions (in thousand metric tons of CO2 equivalent) of 1990 in Saudi Arabia to that in Slovenia?
Make the answer very short. 1525.81. What is the ratio of the SF6 emissions (in thousand metric tons of CO2 equivalent) of 2000 in Saudi Arabia to that in Slovenia?
Offer a very short reply. 632.3. What is the ratio of the SF6 emissions (in thousand metric tons of CO2 equivalent) of 2005 in Saudi Arabia to that in Slovenia?
Provide a short and direct response. 897.18. What is the ratio of the SF6 emissions (in thousand metric tons of CO2 equivalent) of 2008 in Saudi Arabia to that in Slovenia?
Provide a succinct answer. 1009.48. What is the ratio of the SF6 emissions (in thousand metric tons of CO2 equivalent) in 1990 in Singapore to that in Slovenia?
Offer a very short reply. 227.94. What is the ratio of the SF6 emissions (in thousand metric tons of CO2 equivalent) in 2000 in Singapore to that in Slovenia?
Provide a short and direct response. 129.9. What is the ratio of the SF6 emissions (in thousand metric tons of CO2 equivalent) of 2005 in Singapore to that in Slovenia?
Offer a terse response. 136.91. What is the ratio of the SF6 emissions (in thousand metric tons of CO2 equivalent) in 2008 in Singapore to that in Slovenia?
Provide a succinct answer. 167.61. What is the difference between the highest and the second highest SF6 emissions (in thousand metric tons of CO2 equivalent) of 1990?
Provide a short and direct response. 2445.5. What is the difference between the highest and the second highest SF6 emissions (in thousand metric tons of CO2 equivalent) in 2000?
Your answer should be very brief. 7768.6. What is the difference between the highest and the second highest SF6 emissions (in thousand metric tons of CO2 equivalent) of 2005?
Keep it short and to the point. 7316.1. What is the difference between the highest and the second highest SF6 emissions (in thousand metric tons of CO2 equivalent) of 2008?
Offer a terse response. 7126.4. What is the difference between the highest and the lowest SF6 emissions (in thousand metric tons of CO2 equivalent) in 1990?
Provide a succinct answer. 4885.2. What is the difference between the highest and the lowest SF6 emissions (in thousand metric tons of CO2 equivalent) in 2000?
Your answer should be very brief. 9031.2. What is the difference between the highest and the lowest SF6 emissions (in thousand metric tons of CO2 equivalent) of 2005?
Offer a very short reply. 9287.7. What is the difference between the highest and the lowest SF6 emissions (in thousand metric tons of CO2 equivalent) of 2008?
Ensure brevity in your answer.  9445.9. 